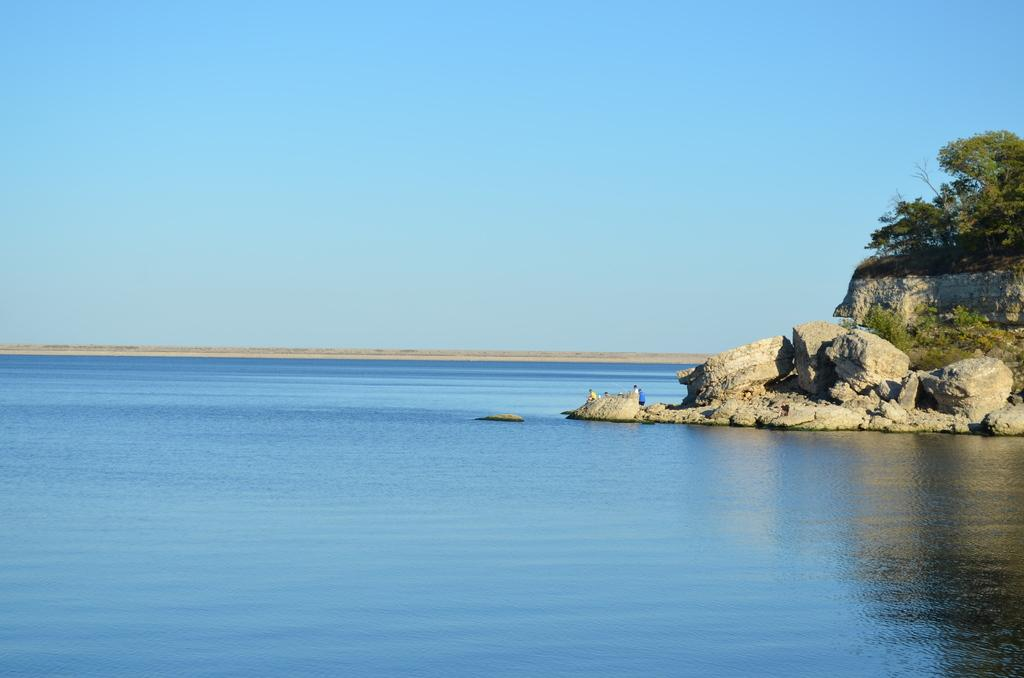What is located in the middle of the image? There is water in the middle of the image. What type of vegetation is on the right side of the image? There are trees on the right side of the image. What else can be seen on the right side of the image? There are rocks on the right side of the image. What is visible at the top of the image? The sky is visible at the top of the image. Can you tell me how many squirrels are exchanging nuts in the wilderness in the image? There are no squirrels or any exchange of nuts in the wilderness depicted in the image. 